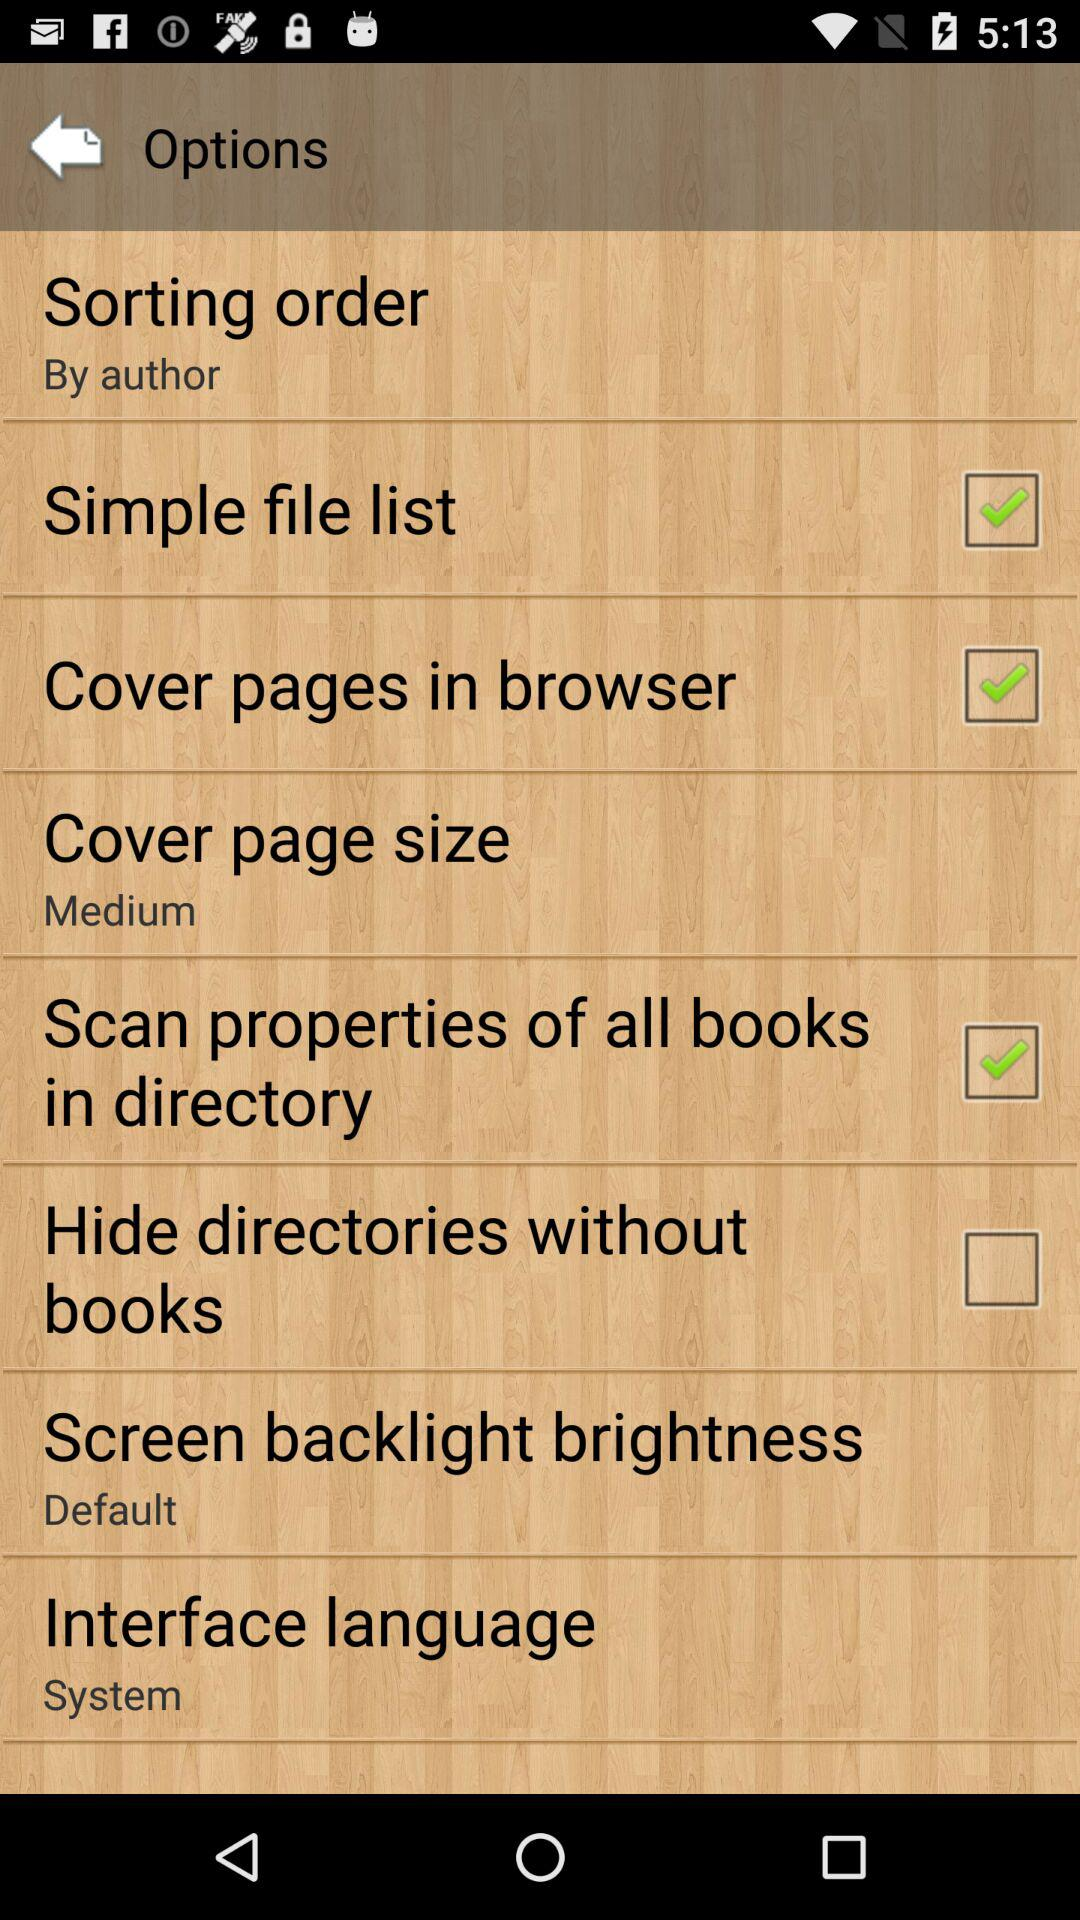What is the setting for the screen backlight brightness? The setting for the screen backlight brightness is "Default". 